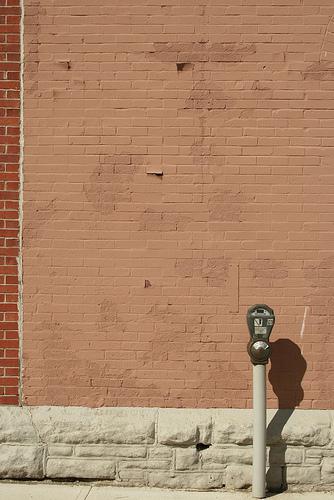How many trees are in this picture?
Answer briefly. 0. Is there a clock?
Short answer required. No. Does the paint on the bricks look fresh?
Keep it brief. No. Where is the parking meter?
Be succinct. By wall. What two types of building materials are shown?
Write a very short answer. Brick and stone. What does the machine do?
Short answer required. Let you park. 